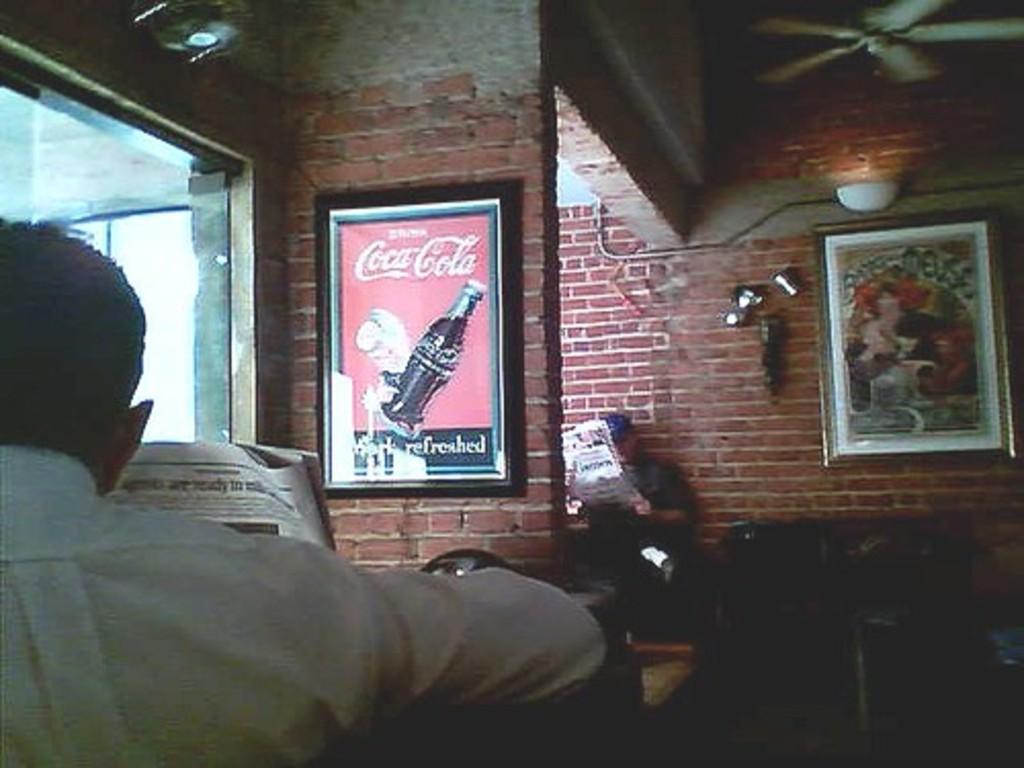Please provide a concise description of this image. In this image there are walls, pictures, fan, people, newspapers, glass window and objects. Pictures are on the wall. 